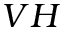<formula> <loc_0><loc_0><loc_500><loc_500>V H</formula> 